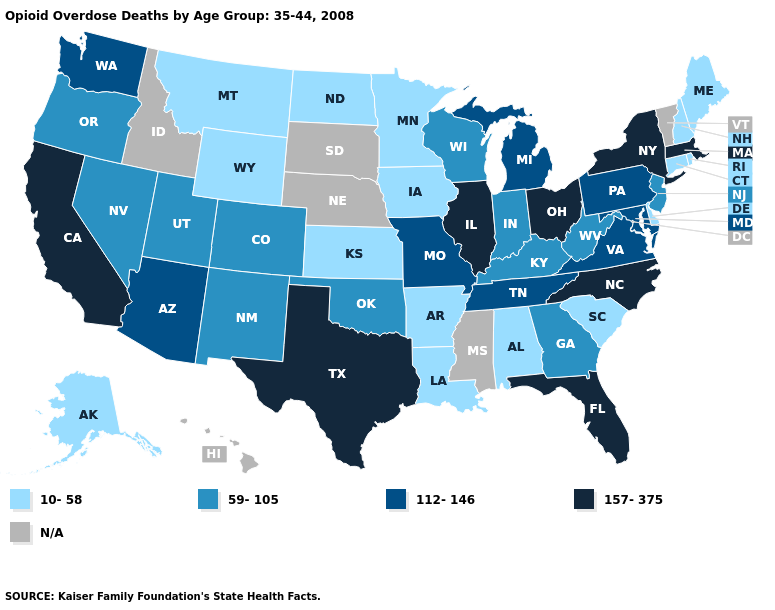Name the states that have a value in the range 112-146?
Write a very short answer. Arizona, Maryland, Michigan, Missouri, Pennsylvania, Tennessee, Virginia, Washington. Name the states that have a value in the range N/A?
Keep it brief. Hawaii, Idaho, Mississippi, Nebraska, South Dakota, Vermont. What is the value of Alabama?
Be succinct. 10-58. Name the states that have a value in the range 10-58?
Short answer required. Alabama, Alaska, Arkansas, Connecticut, Delaware, Iowa, Kansas, Louisiana, Maine, Minnesota, Montana, New Hampshire, North Dakota, Rhode Island, South Carolina, Wyoming. What is the value of Texas?
Keep it brief. 157-375. Does Oklahoma have the highest value in the South?
Concise answer only. No. What is the highest value in the South ?
Concise answer only. 157-375. Name the states that have a value in the range 112-146?
Write a very short answer. Arizona, Maryland, Michigan, Missouri, Pennsylvania, Tennessee, Virginia, Washington. How many symbols are there in the legend?
Keep it brief. 5. Among the states that border Alabama , which have the highest value?
Concise answer only. Florida. What is the highest value in the West ?
Be succinct. 157-375. What is the value of Idaho?
Keep it brief. N/A. Does Montana have the lowest value in the West?
Answer briefly. Yes. What is the lowest value in the USA?
Concise answer only. 10-58. Name the states that have a value in the range 112-146?
Write a very short answer. Arizona, Maryland, Michigan, Missouri, Pennsylvania, Tennessee, Virginia, Washington. 